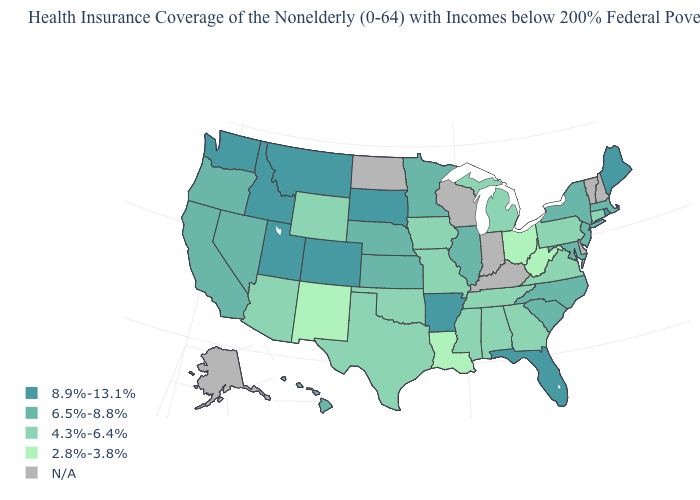Is the legend a continuous bar?
Be succinct. No. What is the value of Virginia?
Answer briefly. 4.3%-6.4%. What is the value of Idaho?
Short answer required. 8.9%-13.1%. Name the states that have a value in the range 2.8%-3.8%?
Give a very brief answer. Louisiana, New Mexico, Ohio, West Virginia. What is the value of North Dakota?
Be succinct. N/A. How many symbols are there in the legend?
Write a very short answer. 5. Name the states that have a value in the range 8.9%-13.1%?
Write a very short answer. Arkansas, Colorado, Florida, Idaho, Maine, Montana, Rhode Island, South Dakota, Utah, Washington. What is the lowest value in the MidWest?
Short answer required. 2.8%-3.8%. What is the value of Idaho?
Quick response, please. 8.9%-13.1%. Name the states that have a value in the range 2.8%-3.8%?
Keep it brief. Louisiana, New Mexico, Ohio, West Virginia. Is the legend a continuous bar?
Be succinct. No. Name the states that have a value in the range 6.5%-8.8%?
Short answer required. California, Hawaii, Illinois, Kansas, Maryland, Massachusetts, Minnesota, Nebraska, Nevada, New Jersey, New York, North Carolina, Oregon, South Carolina. Does the first symbol in the legend represent the smallest category?
Quick response, please. No. Among the states that border Nebraska , does Missouri have the lowest value?
Answer briefly. Yes. 